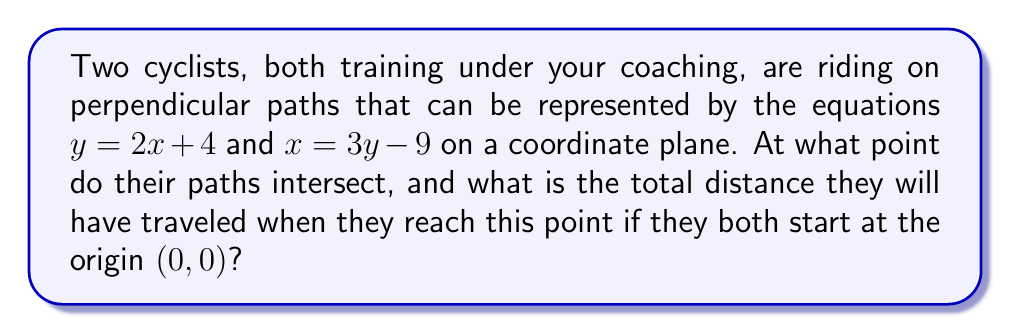Can you answer this question? 1) First, we need to find the intersection point of the two paths:

   Path 1: $y = 2x + 4$
   Path 2: $x = 3y - 9$

2) Substitute the equation of Path 2 into Path 1:
   $y = 2(3y - 9) + 4$
   $y = 6y - 18 + 4$
   $y = 6y - 14$

3) Solve for y:
   $-5y = -14$
   $y = \frac{14}{5} = 2.8$

4) Substitute this y-value back into either equation to find x:
   $x = 3(2.8) - 9 = 8.4 - 9 = -0.6$

5) So, the intersection point is $(-0.6, 2.8)$

6) Now, calculate the distance each cyclist travels:

   Cyclist 1 (on $y = 2x + 4$):
   Distance = $\sqrt{(-0.6 - 0)^2 + (2.8 - 0)^2} = \sqrt{0.36 + 7.84} = \sqrt{8.2} \approx 2.86$

   Cyclist 2 (on $x = 3y - 9$):
   Distance = $\sqrt{(-0.6 - 0)^2 + (2.8 - 0)^2} = \sqrt{0.36 + 7.84} = \sqrt{8.2} \approx 2.86$

7) Total distance: $2.86 + 2.86 = 5.72$ units
Answer: Intersection point: $(-0.6, 2.8)$; Total distance: $5.72$ units 